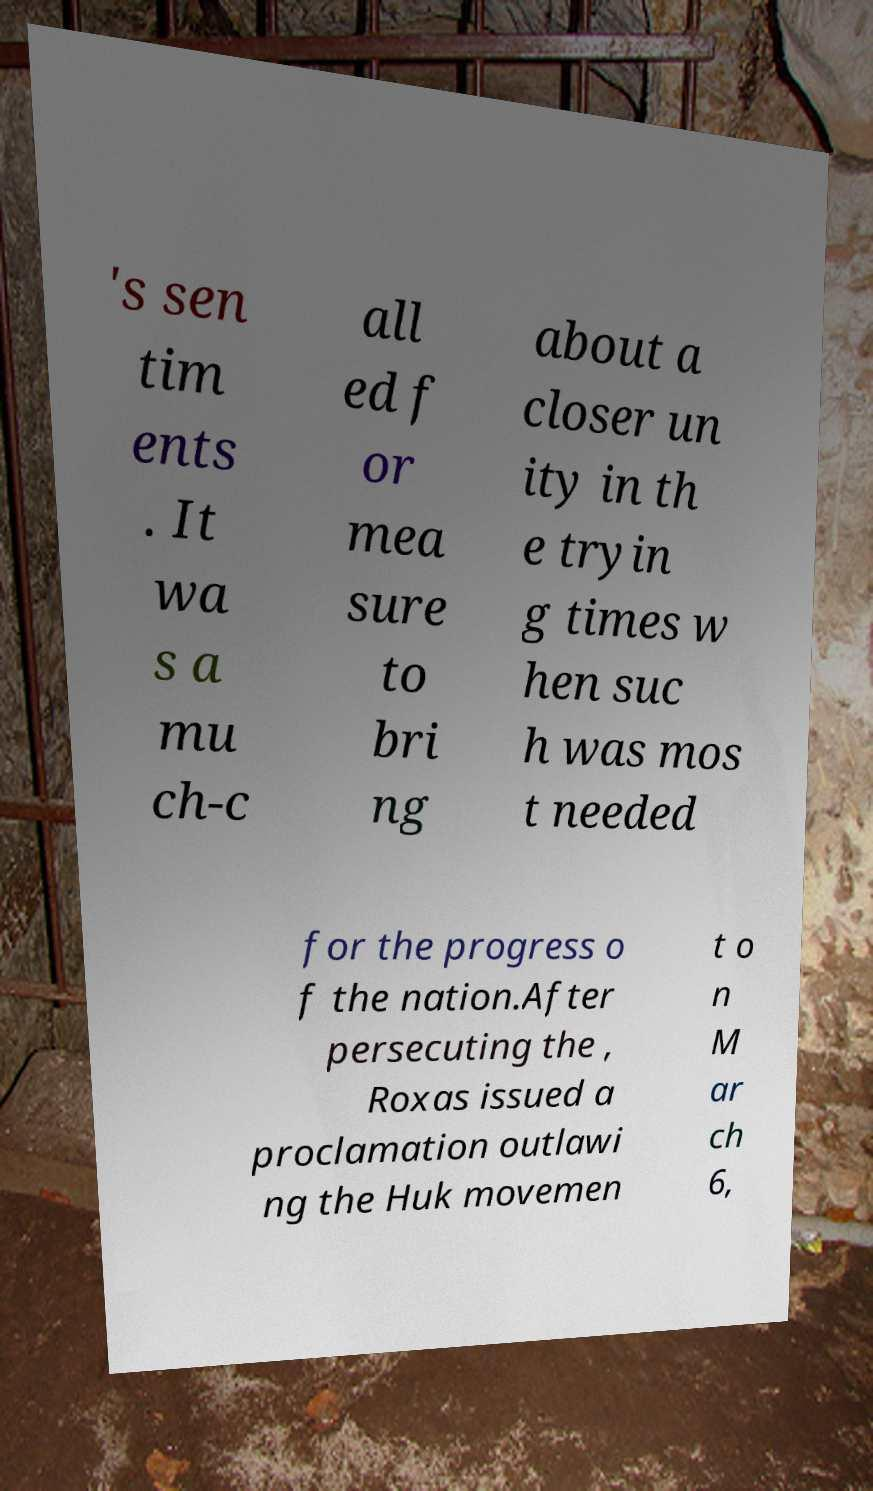What messages or text are displayed in this image? I need them in a readable, typed format. 's sen tim ents . It wa s a mu ch-c all ed f or mea sure to bri ng about a closer un ity in th e tryin g times w hen suc h was mos t needed for the progress o f the nation.After persecuting the , Roxas issued a proclamation outlawi ng the Huk movemen t o n M ar ch 6, 